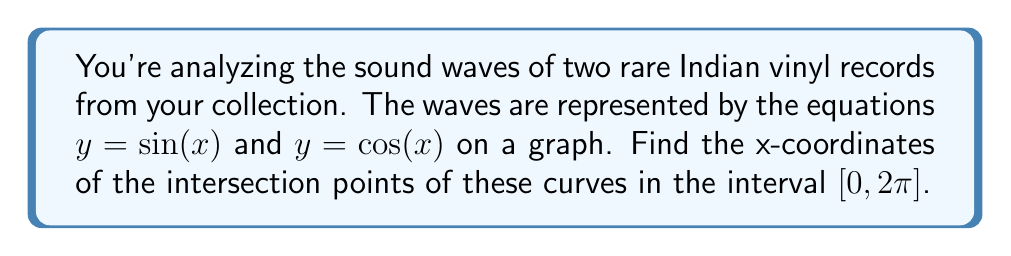Teach me how to tackle this problem. 1) To find the intersection points, we need to solve the equation:
   $\sin(x) = \cos(x)$

2) We can rewrite this as:
   $\sin(x) - \cos(x) = 0$

3) Recall the trigonometric identity:
   $\sin(x) - \cos(x) = \sqrt{2} \sin(x - \frac{\pi}{4})$

4) So our equation becomes:
   $\sqrt{2} \sin(x - \frac{\pi}{4}) = 0$

5) The sine function equals zero when its argument is a multiple of $\pi$. So:
   $x - \frac{\pi}{4} = n\pi$, where $n$ is an integer

6) Solving for $x$:
   $x = n\pi + \frac{\pi}{4}$

7) In the interval $[0, 2\pi]$, this equation has two solutions:
   When $n = 0$: $x = \frac{\pi}{4}$
   When $n = 1$: $x = \frac{5\pi}{4}$

8) We can verify these solutions by substituting them back into the original equations:
   $\sin(\frac{\pi}{4}) = \cos(\frac{\pi}{4}) = \frac{\sqrt{2}}{2}$
   $\sin(\frac{5\pi}{4}) = \cos(\frac{5\pi}{4}) = -\frac{\sqrt{2}}{2}$
Answer: $x = \frac{\pi}{4}$ and $x = \frac{5\pi}{4}$ 